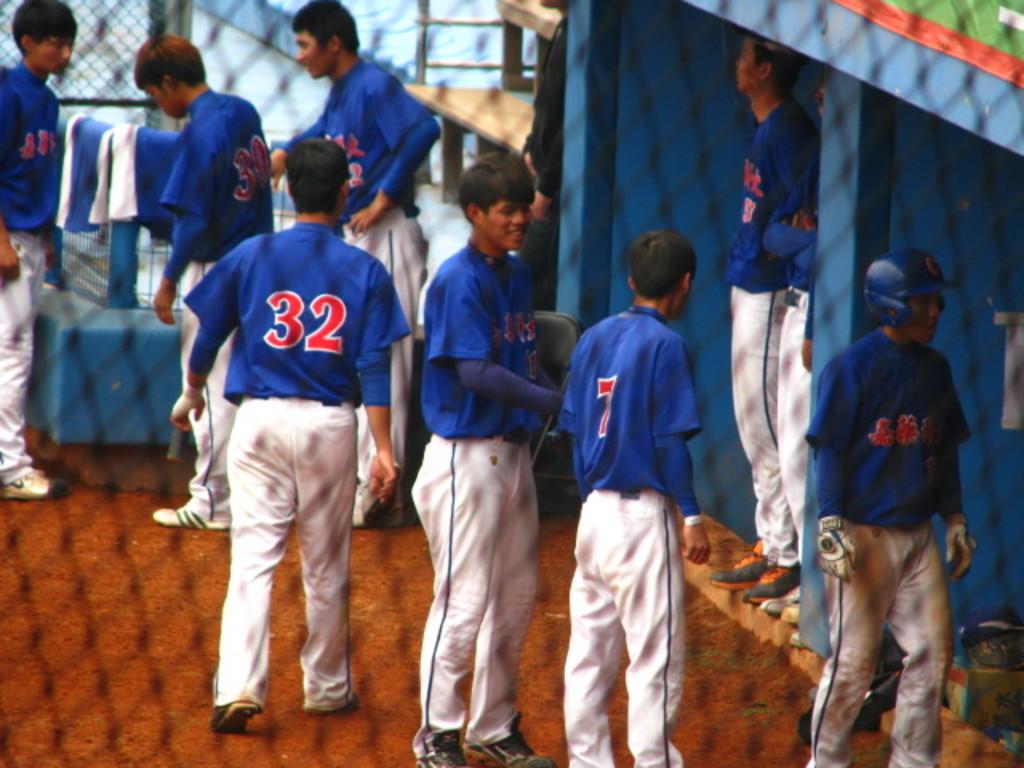What number is on the jersey second to right?
Keep it short and to the point. 7. What number is on the boys jersey standing closest to the left?
Your response must be concise. 32. 